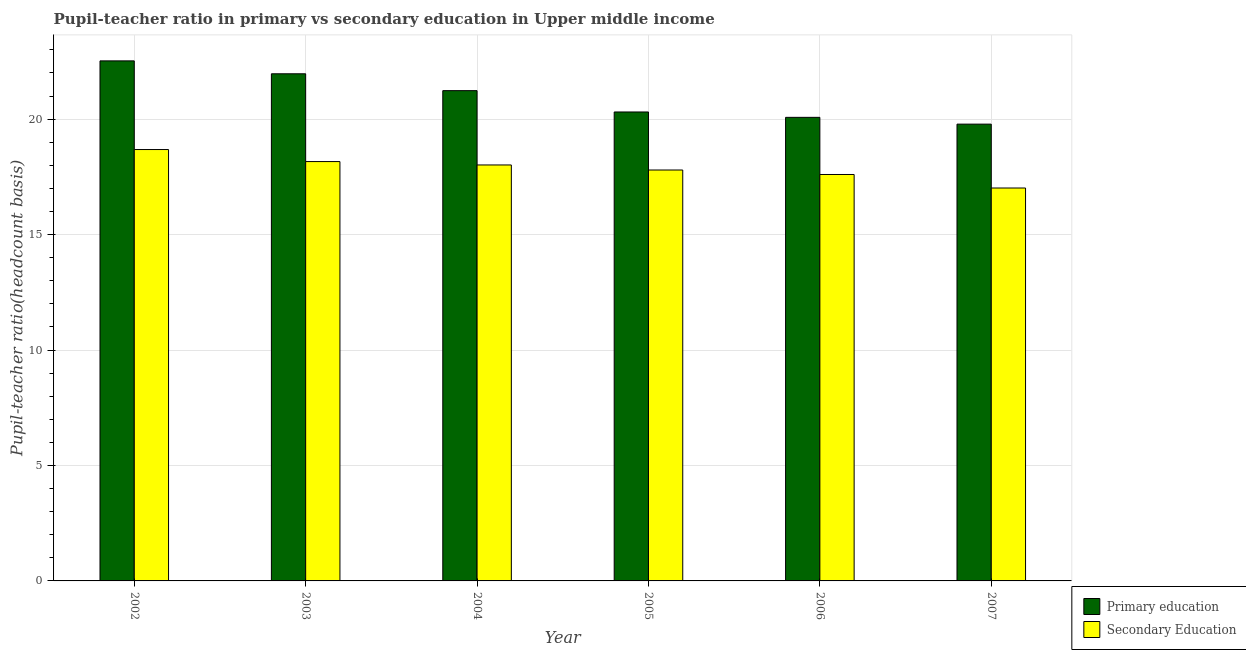How many different coloured bars are there?
Make the answer very short. 2. How many groups of bars are there?
Offer a very short reply. 6. Are the number of bars per tick equal to the number of legend labels?
Offer a terse response. Yes. Are the number of bars on each tick of the X-axis equal?
Your answer should be compact. Yes. How many bars are there on the 6th tick from the right?
Offer a terse response. 2. In how many cases, is the number of bars for a given year not equal to the number of legend labels?
Your answer should be very brief. 0. What is the pupil teacher ratio on secondary education in 2002?
Ensure brevity in your answer.  18.68. Across all years, what is the maximum pupil teacher ratio on secondary education?
Keep it short and to the point. 18.68. Across all years, what is the minimum pupil-teacher ratio in primary education?
Your answer should be compact. 19.79. In which year was the pupil-teacher ratio in primary education maximum?
Your response must be concise. 2002. In which year was the pupil teacher ratio on secondary education minimum?
Provide a short and direct response. 2007. What is the total pupil-teacher ratio in primary education in the graph?
Your response must be concise. 125.9. What is the difference between the pupil teacher ratio on secondary education in 2005 and that in 2006?
Offer a terse response. 0.19. What is the difference between the pupil-teacher ratio in primary education in 2005 and the pupil teacher ratio on secondary education in 2006?
Your answer should be compact. 0.23. What is the average pupil teacher ratio on secondary education per year?
Ensure brevity in your answer.  17.88. In how many years, is the pupil-teacher ratio in primary education greater than 9?
Your answer should be compact. 6. What is the ratio of the pupil teacher ratio on secondary education in 2005 to that in 2006?
Provide a succinct answer. 1.01. Is the difference between the pupil teacher ratio on secondary education in 2005 and 2006 greater than the difference between the pupil-teacher ratio in primary education in 2005 and 2006?
Keep it short and to the point. No. What is the difference between the highest and the second highest pupil teacher ratio on secondary education?
Provide a short and direct response. 0.52. What is the difference between the highest and the lowest pupil-teacher ratio in primary education?
Your response must be concise. 2.74. Is the sum of the pupil teacher ratio on secondary education in 2004 and 2006 greater than the maximum pupil-teacher ratio in primary education across all years?
Provide a short and direct response. Yes. What does the 1st bar from the left in 2002 represents?
Provide a short and direct response. Primary education. What does the 1st bar from the right in 2002 represents?
Make the answer very short. Secondary Education. How many bars are there?
Make the answer very short. 12. How many legend labels are there?
Your answer should be very brief. 2. How are the legend labels stacked?
Give a very brief answer. Vertical. What is the title of the graph?
Provide a succinct answer. Pupil-teacher ratio in primary vs secondary education in Upper middle income. Does "Goods and services" appear as one of the legend labels in the graph?
Ensure brevity in your answer.  No. What is the label or title of the Y-axis?
Offer a terse response. Pupil-teacher ratio(headcount basis). What is the Pupil-teacher ratio(headcount basis) of Primary education in 2002?
Offer a very short reply. 22.53. What is the Pupil-teacher ratio(headcount basis) of Secondary Education in 2002?
Give a very brief answer. 18.68. What is the Pupil-teacher ratio(headcount basis) of Primary education in 2003?
Offer a very short reply. 21.97. What is the Pupil-teacher ratio(headcount basis) in Secondary Education in 2003?
Your answer should be very brief. 18.16. What is the Pupil-teacher ratio(headcount basis) of Primary education in 2004?
Keep it short and to the point. 21.24. What is the Pupil-teacher ratio(headcount basis) of Secondary Education in 2004?
Offer a very short reply. 18.02. What is the Pupil-teacher ratio(headcount basis) of Primary education in 2005?
Provide a succinct answer. 20.31. What is the Pupil-teacher ratio(headcount basis) in Secondary Education in 2005?
Offer a very short reply. 17.8. What is the Pupil-teacher ratio(headcount basis) in Primary education in 2006?
Keep it short and to the point. 20.08. What is the Pupil-teacher ratio(headcount basis) in Secondary Education in 2006?
Make the answer very short. 17.6. What is the Pupil-teacher ratio(headcount basis) of Primary education in 2007?
Give a very brief answer. 19.79. What is the Pupil-teacher ratio(headcount basis) in Secondary Education in 2007?
Ensure brevity in your answer.  17.02. Across all years, what is the maximum Pupil-teacher ratio(headcount basis) of Primary education?
Keep it short and to the point. 22.53. Across all years, what is the maximum Pupil-teacher ratio(headcount basis) in Secondary Education?
Your answer should be compact. 18.68. Across all years, what is the minimum Pupil-teacher ratio(headcount basis) in Primary education?
Ensure brevity in your answer.  19.79. Across all years, what is the minimum Pupil-teacher ratio(headcount basis) in Secondary Education?
Provide a succinct answer. 17.02. What is the total Pupil-teacher ratio(headcount basis) in Primary education in the graph?
Your response must be concise. 125.9. What is the total Pupil-teacher ratio(headcount basis) of Secondary Education in the graph?
Offer a terse response. 107.29. What is the difference between the Pupil-teacher ratio(headcount basis) in Primary education in 2002 and that in 2003?
Provide a short and direct response. 0.56. What is the difference between the Pupil-teacher ratio(headcount basis) of Secondary Education in 2002 and that in 2003?
Ensure brevity in your answer.  0.52. What is the difference between the Pupil-teacher ratio(headcount basis) in Primary education in 2002 and that in 2004?
Give a very brief answer. 1.29. What is the difference between the Pupil-teacher ratio(headcount basis) of Secondary Education in 2002 and that in 2004?
Make the answer very short. 0.67. What is the difference between the Pupil-teacher ratio(headcount basis) of Primary education in 2002 and that in 2005?
Offer a very short reply. 2.21. What is the difference between the Pupil-teacher ratio(headcount basis) in Secondary Education in 2002 and that in 2005?
Provide a succinct answer. 0.89. What is the difference between the Pupil-teacher ratio(headcount basis) of Primary education in 2002 and that in 2006?
Your answer should be very brief. 2.45. What is the difference between the Pupil-teacher ratio(headcount basis) of Secondary Education in 2002 and that in 2006?
Offer a very short reply. 1.08. What is the difference between the Pupil-teacher ratio(headcount basis) of Primary education in 2002 and that in 2007?
Offer a very short reply. 2.74. What is the difference between the Pupil-teacher ratio(headcount basis) of Secondary Education in 2002 and that in 2007?
Offer a terse response. 1.67. What is the difference between the Pupil-teacher ratio(headcount basis) in Primary education in 2003 and that in 2004?
Your response must be concise. 0.73. What is the difference between the Pupil-teacher ratio(headcount basis) of Secondary Education in 2003 and that in 2004?
Offer a very short reply. 0.15. What is the difference between the Pupil-teacher ratio(headcount basis) of Primary education in 2003 and that in 2005?
Provide a short and direct response. 1.65. What is the difference between the Pupil-teacher ratio(headcount basis) in Secondary Education in 2003 and that in 2005?
Provide a succinct answer. 0.37. What is the difference between the Pupil-teacher ratio(headcount basis) of Primary education in 2003 and that in 2006?
Keep it short and to the point. 1.89. What is the difference between the Pupil-teacher ratio(headcount basis) in Secondary Education in 2003 and that in 2006?
Give a very brief answer. 0.56. What is the difference between the Pupil-teacher ratio(headcount basis) in Primary education in 2003 and that in 2007?
Provide a short and direct response. 2.18. What is the difference between the Pupil-teacher ratio(headcount basis) of Secondary Education in 2003 and that in 2007?
Make the answer very short. 1.15. What is the difference between the Pupil-teacher ratio(headcount basis) in Primary education in 2004 and that in 2005?
Offer a very short reply. 0.92. What is the difference between the Pupil-teacher ratio(headcount basis) in Secondary Education in 2004 and that in 2005?
Your answer should be very brief. 0.22. What is the difference between the Pupil-teacher ratio(headcount basis) in Primary education in 2004 and that in 2006?
Provide a succinct answer. 1.16. What is the difference between the Pupil-teacher ratio(headcount basis) of Secondary Education in 2004 and that in 2006?
Your response must be concise. 0.41. What is the difference between the Pupil-teacher ratio(headcount basis) of Primary education in 2004 and that in 2007?
Keep it short and to the point. 1.45. What is the difference between the Pupil-teacher ratio(headcount basis) of Secondary Education in 2004 and that in 2007?
Provide a succinct answer. 1. What is the difference between the Pupil-teacher ratio(headcount basis) in Primary education in 2005 and that in 2006?
Ensure brevity in your answer.  0.23. What is the difference between the Pupil-teacher ratio(headcount basis) of Secondary Education in 2005 and that in 2006?
Your answer should be very brief. 0.19. What is the difference between the Pupil-teacher ratio(headcount basis) of Primary education in 2005 and that in 2007?
Your answer should be very brief. 0.53. What is the difference between the Pupil-teacher ratio(headcount basis) of Secondary Education in 2005 and that in 2007?
Your response must be concise. 0.78. What is the difference between the Pupil-teacher ratio(headcount basis) in Primary education in 2006 and that in 2007?
Provide a short and direct response. 0.29. What is the difference between the Pupil-teacher ratio(headcount basis) in Secondary Education in 2006 and that in 2007?
Give a very brief answer. 0.59. What is the difference between the Pupil-teacher ratio(headcount basis) of Primary education in 2002 and the Pupil-teacher ratio(headcount basis) of Secondary Education in 2003?
Your response must be concise. 4.36. What is the difference between the Pupil-teacher ratio(headcount basis) in Primary education in 2002 and the Pupil-teacher ratio(headcount basis) in Secondary Education in 2004?
Give a very brief answer. 4.51. What is the difference between the Pupil-teacher ratio(headcount basis) in Primary education in 2002 and the Pupil-teacher ratio(headcount basis) in Secondary Education in 2005?
Your response must be concise. 4.73. What is the difference between the Pupil-teacher ratio(headcount basis) of Primary education in 2002 and the Pupil-teacher ratio(headcount basis) of Secondary Education in 2006?
Ensure brevity in your answer.  4.92. What is the difference between the Pupil-teacher ratio(headcount basis) of Primary education in 2002 and the Pupil-teacher ratio(headcount basis) of Secondary Education in 2007?
Your answer should be compact. 5.51. What is the difference between the Pupil-teacher ratio(headcount basis) in Primary education in 2003 and the Pupil-teacher ratio(headcount basis) in Secondary Education in 2004?
Offer a terse response. 3.95. What is the difference between the Pupil-teacher ratio(headcount basis) of Primary education in 2003 and the Pupil-teacher ratio(headcount basis) of Secondary Education in 2005?
Keep it short and to the point. 4.17. What is the difference between the Pupil-teacher ratio(headcount basis) in Primary education in 2003 and the Pupil-teacher ratio(headcount basis) in Secondary Education in 2006?
Make the answer very short. 4.36. What is the difference between the Pupil-teacher ratio(headcount basis) of Primary education in 2003 and the Pupil-teacher ratio(headcount basis) of Secondary Education in 2007?
Provide a succinct answer. 4.95. What is the difference between the Pupil-teacher ratio(headcount basis) of Primary education in 2004 and the Pupil-teacher ratio(headcount basis) of Secondary Education in 2005?
Offer a terse response. 3.44. What is the difference between the Pupil-teacher ratio(headcount basis) of Primary education in 2004 and the Pupil-teacher ratio(headcount basis) of Secondary Education in 2006?
Keep it short and to the point. 3.63. What is the difference between the Pupil-teacher ratio(headcount basis) in Primary education in 2004 and the Pupil-teacher ratio(headcount basis) in Secondary Education in 2007?
Provide a short and direct response. 4.22. What is the difference between the Pupil-teacher ratio(headcount basis) in Primary education in 2005 and the Pupil-teacher ratio(headcount basis) in Secondary Education in 2006?
Give a very brief answer. 2.71. What is the difference between the Pupil-teacher ratio(headcount basis) in Primary education in 2005 and the Pupil-teacher ratio(headcount basis) in Secondary Education in 2007?
Your answer should be compact. 3.29. What is the difference between the Pupil-teacher ratio(headcount basis) in Primary education in 2006 and the Pupil-teacher ratio(headcount basis) in Secondary Education in 2007?
Ensure brevity in your answer.  3.06. What is the average Pupil-teacher ratio(headcount basis) in Primary education per year?
Keep it short and to the point. 20.98. What is the average Pupil-teacher ratio(headcount basis) in Secondary Education per year?
Provide a short and direct response. 17.88. In the year 2002, what is the difference between the Pupil-teacher ratio(headcount basis) of Primary education and Pupil-teacher ratio(headcount basis) of Secondary Education?
Make the answer very short. 3.84. In the year 2003, what is the difference between the Pupil-teacher ratio(headcount basis) in Primary education and Pupil-teacher ratio(headcount basis) in Secondary Education?
Provide a short and direct response. 3.8. In the year 2004, what is the difference between the Pupil-teacher ratio(headcount basis) in Primary education and Pupil-teacher ratio(headcount basis) in Secondary Education?
Provide a succinct answer. 3.22. In the year 2005, what is the difference between the Pupil-teacher ratio(headcount basis) of Primary education and Pupil-teacher ratio(headcount basis) of Secondary Education?
Your answer should be very brief. 2.51. In the year 2006, what is the difference between the Pupil-teacher ratio(headcount basis) of Primary education and Pupil-teacher ratio(headcount basis) of Secondary Education?
Keep it short and to the point. 2.48. In the year 2007, what is the difference between the Pupil-teacher ratio(headcount basis) of Primary education and Pupil-teacher ratio(headcount basis) of Secondary Education?
Keep it short and to the point. 2.77. What is the ratio of the Pupil-teacher ratio(headcount basis) in Primary education in 2002 to that in 2003?
Your answer should be very brief. 1.03. What is the ratio of the Pupil-teacher ratio(headcount basis) in Secondary Education in 2002 to that in 2003?
Offer a very short reply. 1.03. What is the ratio of the Pupil-teacher ratio(headcount basis) in Primary education in 2002 to that in 2004?
Your answer should be compact. 1.06. What is the ratio of the Pupil-teacher ratio(headcount basis) in Secondary Education in 2002 to that in 2004?
Keep it short and to the point. 1.04. What is the ratio of the Pupil-teacher ratio(headcount basis) in Primary education in 2002 to that in 2005?
Keep it short and to the point. 1.11. What is the ratio of the Pupil-teacher ratio(headcount basis) in Secondary Education in 2002 to that in 2005?
Make the answer very short. 1.05. What is the ratio of the Pupil-teacher ratio(headcount basis) in Primary education in 2002 to that in 2006?
Offer a terse response. 1.12. What is the ratio of the Pupil-teacher ratio(headcount basis) in Secondary Education in 2002 to that in 2006?
Provide a succinct answer. 1.06. What is the ratio of the Pupil-teacher ratio(headcount basis) in Primary education in 2002 to that in 2007?
Keep it short and to the point. 1.14. What is the ratio of the Pupil-teacher ratio(headcount basis) of Secondary Education in 2002 to that in 2007?
Keep it short and to the point. 1.1. What is the ratio of the Pupil-teacher ratio(headcount basis) in Primary education in 2003 to that in 2004?
Your answer should be very brief. 1.03. What is the ratio of the Pupil-teacher ratio(headcount basis) of Secondary Education in 2003 to that in 2004?
Offer a very short reply. 1.01. What is the ratio of the Pupil-teacher ratio(headcount basis) of Primary education in 2003 to that in 2005?
Make the answer very short. 1.08. What is the ratio of the Pupil-teacher ratio(headcount basis) in Secondary Education in 2003 to that in 2005?
Give a very brief answer. 1.02. What is the ratio of the Pupil-teacher ratio(headcount basis) of Primary education in 2003 to that in 2006?
Your response must be concise. 1.09. What is the ratio of the Pupil-teacher ratio(headcount basis) in Secondary Education in 2003 to that in 2006?
Provide a short and direct response. 1.03. What is the ratio of the Pupil-teacher ratio(headcount basis) in Primary education in 2003 to that in 2007?
Make the answer very short. 1.11. What is the ratio of the Pupil-teacher ratio(headcount basis) of Secondary Education in 2003 to that in 2007?
Your answer should be compact. 1.07. What is the ratio of the Pupil-teacher ratio(headcount basis) of Primary education in 2004 to that in 2005?
Your response must be concise. 1.05. What is the ratio of the Pupil-teacher ratio(headcount basis) of Secondary Education in 2004 to that in 2005?
Offer a very short reply. 1.01. What is the ratio of the Pupil-teacher ratio(headcount basis) of Primary education in 2004 to that in 2006?
Keep it short and to the point. 1.06. What is the ratio of the Pupil-teacher ratio(headcount basis) of Secondary Education in 2004 to that in 2006?
Offer a very short reply. 1.02. What is the ratio of the Pupil-teacher ratio(headcount basis) of Primary education in 2004 to that in 2007?
Keep it short and to the point. 1.07. What is the ratio of the Pupil-teacher ratio(headcount basis) of Secondary Education in 2004 to that in 2007?
Provide a short and direct response. 1.06. What is the ratio of the Pupil-teacher ratio(headcount basis) of Primary education in 2005 to that in 2006?
Make the answer very short. 1.01. What is the ratio of the Pupil-teacher ratio(headcount basis) of Secondary Education in 2005 to that in 2006?
Keep it short and to the point. 1.01. What is the ratio of the Pupil-teacher ratio(headcount basis) of Primary education in 2005 to that in 2007?
Your answer should be very brief. 1.03. What is the ratio of the Pupil-teacher ratio(headcount basis) of Secondary Education in 2005 to that in 2007?
Your answer should be very brief. 1.05. What is the ratio of the Pupil-teacher ratio(headcount basis) in Primary education in 2006 to that in 2007?
Give a very brief answer. 1.01. What is the ratio of the Pupil-teacher ratio(headcount basis) of Secondary Education in 2006 to that in 2007?
Your answer should be compact. 1.03. What is the difference between the highest and the second highest Pupil-teacher ratio(headcount basis) in Primary education?
Provide a short and direct response. 0.56. What is the difference between the highest and the second highest Pupil-teacher ratio(headcount basis) of Secondary Education?
Give a very brief answer. 0.52. What is the difference between the highest and the lowest Pupil-teacher ratio(headcount basis) in Primary education?
Keep it short and to the point. 2.74. What is the difference between the highest and the lowest Pupil-teacher ratio(headcount basis) of Secondary Education?
Provide a short and direct response. 1.67. 